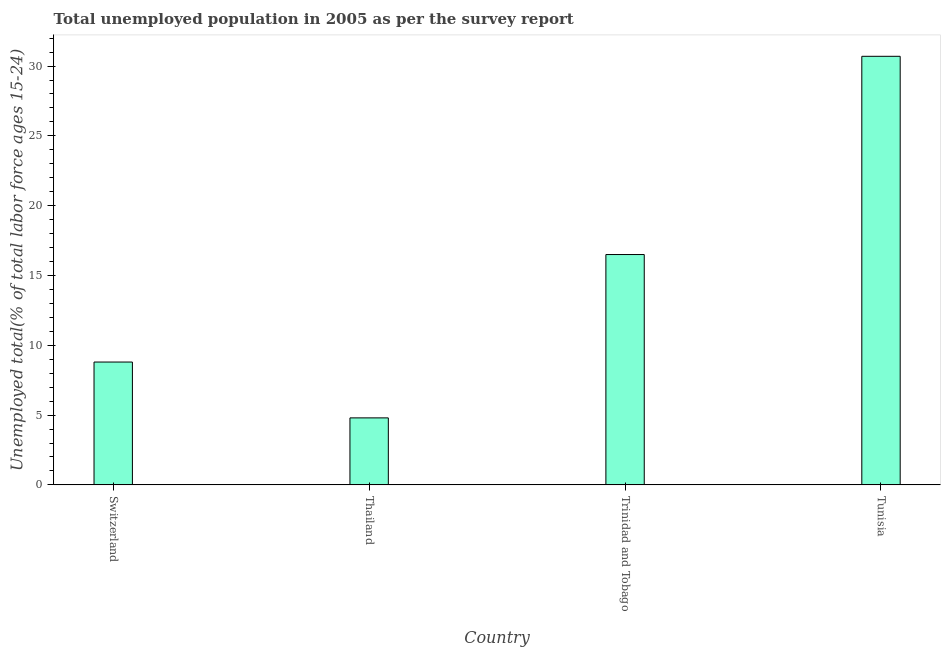Does the graph contain grids?
Provide a succinct answer. No. What is the title of the graph?
Ensure brevity in your answer.  Total unemployed population in 2005 as per the survey report. What is the label or title of the X-axis?
Provide a succinct answer. Country. What is the label or title of the Y-axis?
Make the answer very short. Unemployed total(% of total labor force ages 15-24). What is the unemployed youth in Thailand?
Provide a succinct answer. 4.8. Across all countries, what is the maximum unemployed youth?
Offer a very short reply. 30.7. Across all countries, what is the minimum unemployed youth?
Make the answer very short. 4.8. In which country was the unemployed youth maximum?
Make the answer very short. Tunisia. In which country was the unemployed youth minimum?
Provide a short and direct response. Thailand. What is the sum of the unemployed youth?
Ensure brevity in your answer.  60.8. What is the difference between the unemployed youth in Trinidad and Tobago and Tunisia?
Provide a succinct answer. -14.2. What is the average unemployed youth per country?
Make the answer very short. 15.2. What is the median unemployed youth?
Offer a terse response. 12.65. In how many countries, is the unemployed youth greater than 29 %?
Ensure brevity in your answer.  1. What is the ratio of the unemployed youth in Switzerland to that in Thailand?
Give a very brief answer. 1.83. What is the difference between the highest and the second highest unemployed youth?
Provide a short and direct response. 14.2. Is the sum of the unemployed youth in Thailand and Tunisia greater than the maximum unemployed youth across all countries?
Make the answer very short. Yes. What is the difference between the highest and the lowest unemployed youth?
Ensure brevity in your answer.  25.9. In how many countries, is the unemployed youth greater than the average unemployed youth taken over all countries?
Offer a terse response. 2. How many bars are there?
Ensure brevity in your answer.  4. Are all the bars in the graph horizontal?
Offer a very short reply. No. What is the Unemployed total(% of total labor force ages 15-24) of Switzerland?
Ensure brevity in your answer.  8.8. What is the Unemployed total(% of total labor force ages 15-24) of Thailand?
Your response must be concise. 4.8. What is the Unemployed total(% of total labor force ages 15-24) in Tunisia?
Your answer should be very brief. 30.7. What is the difference between the Unemployed total(% of total labor force ages 15-24) in Switzerland and Tunisia?
Your answer should be very brief. -21.9. What is the difference between the Unemployed total(% of total labor force ages 15-24) in Thailand and Tunisia?
Your answer should be compact. -25.9. What is the difference between the Unemployed total(% of total labor force ages 15-24) in Trinidad and Tobago and Tunisia?
Give a very brief answer. -14.2. What is the ratio of the Unemployed total(% of total labor force ages 15-24) in Switzerland to that in Thailand?
Ensure brevity in your answer.  1.83. What is the ratio of the Unemployed total(% of total labor force ages 15-24) in Switzerland to that in Trinidad and Tobago?
Your answer should be very brief. 0.53. What is the ratio of the Unemployed total(% of total labor force ages 15-24) in Switzerland to that in Tunisia?
Give a very brief answer. 0.29. What is the ratio of the Unemployed total(% of total labor force ages 15-24) in Thailand to that in Trinidad and Tobago?
Offer a terse response. 0.29. What is the ratio of the Unemployed total(% of total labor force ages 15-24) in Thailand to that in Tunisia?
Make the answer very short. 0.16. What is the ratio of the Unemployed total(% of total labor force ages 15-24) in Trinidad and Tobago to that in Tunisia?
Offer a terse response. 0.54. 